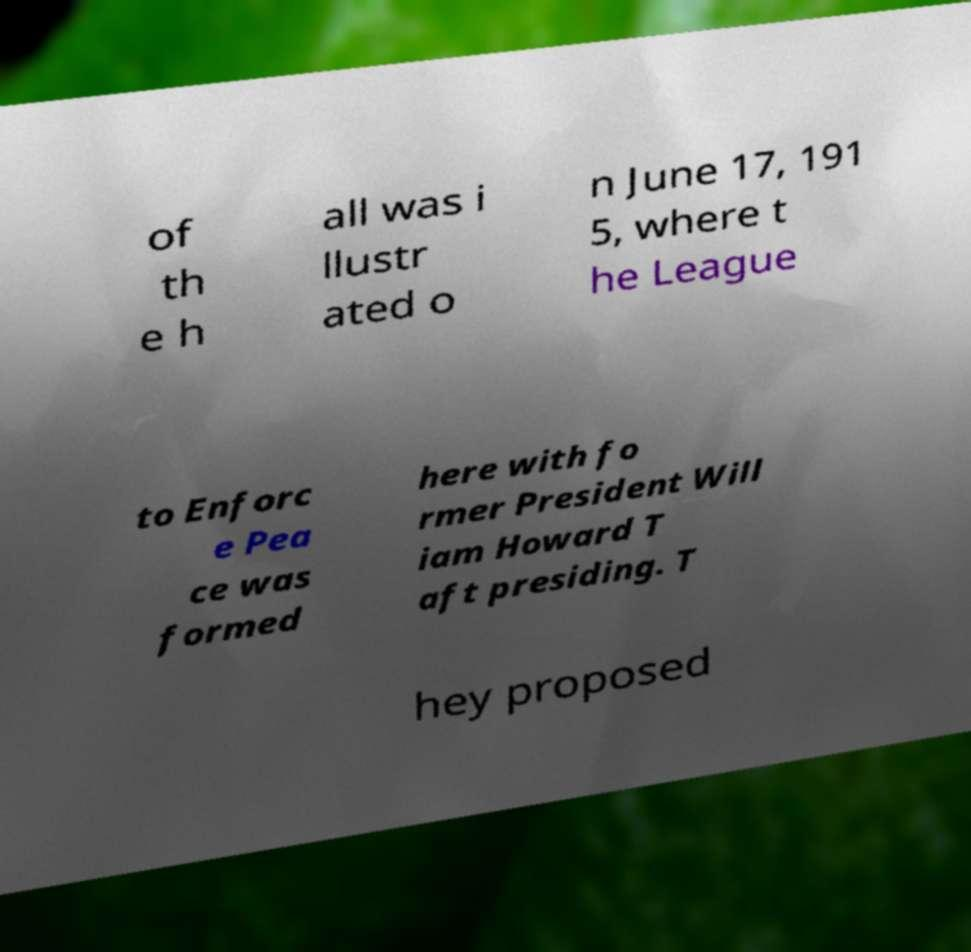Please read and relay the text visible in this image. What does it say? of th e h all was i llustr ated o n June 17, 191 5, where t he League to Enforc e Pea ce was formed here with fo rmer President Will iam Howard T aft presiding. T hey proposed 